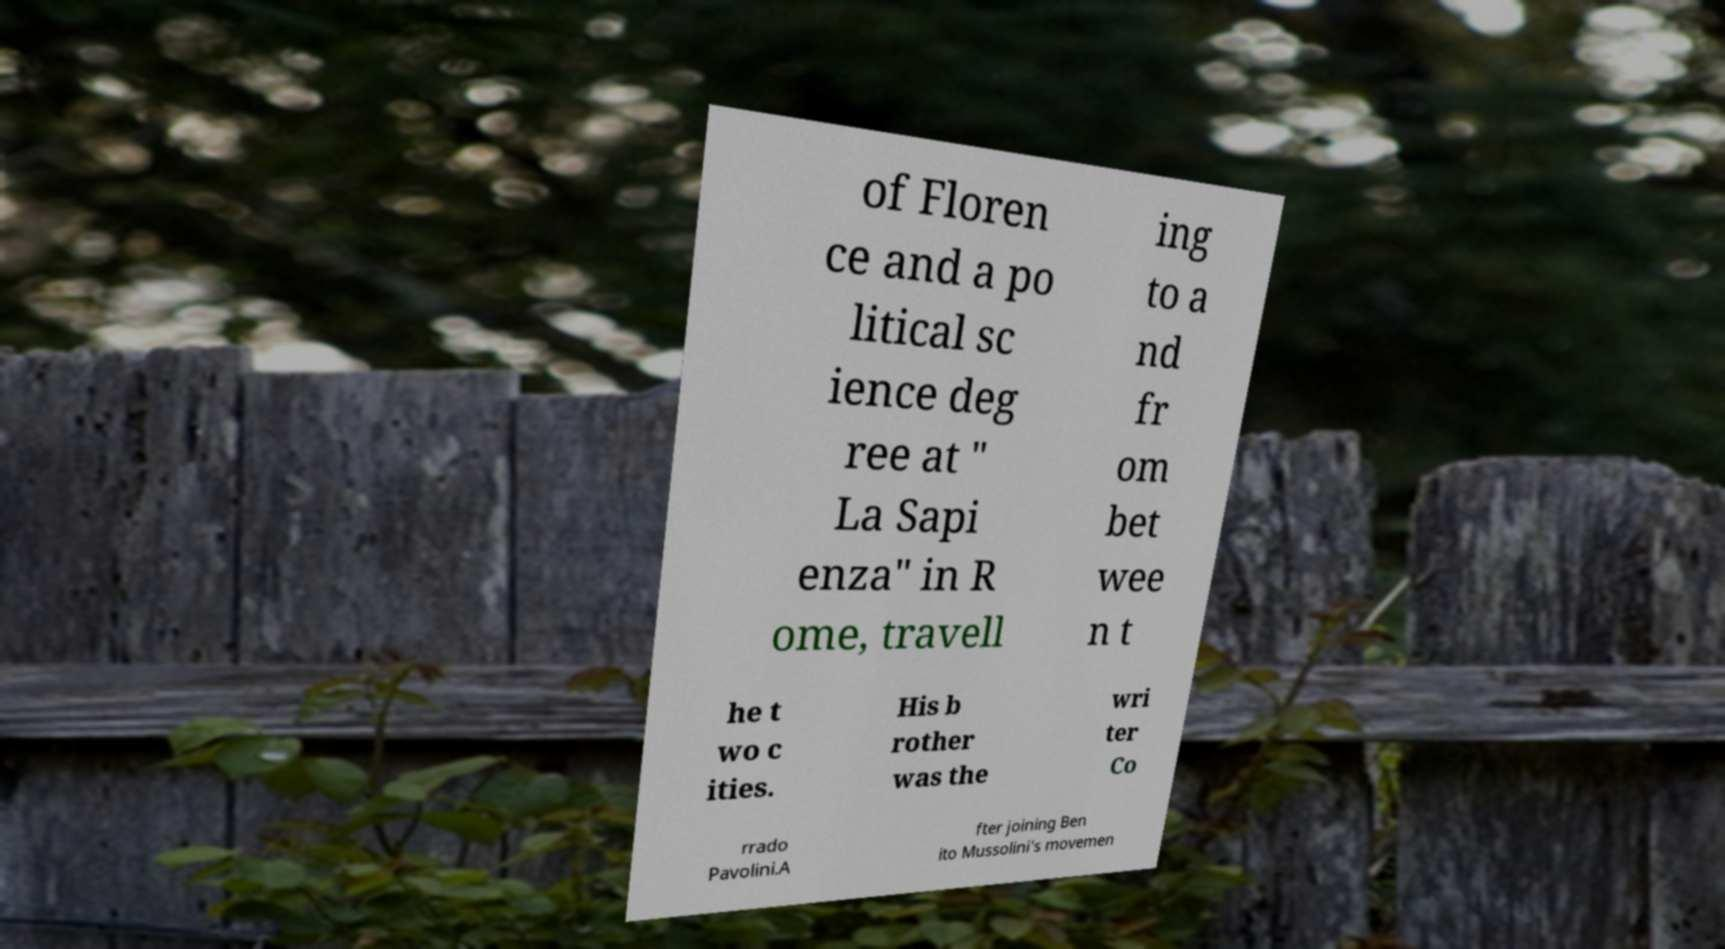Can you accurately transcribe the text from the provided image for me? of Floren ce and a po litical sc ience deg ree at " La Sapi enza" in R ome, travell ing to a nd fr om bet wee n t he t wo c ities. His b rother was the wri ter Co rrado Pavolini.A fter joining Ben ito Mussolini's movemen 